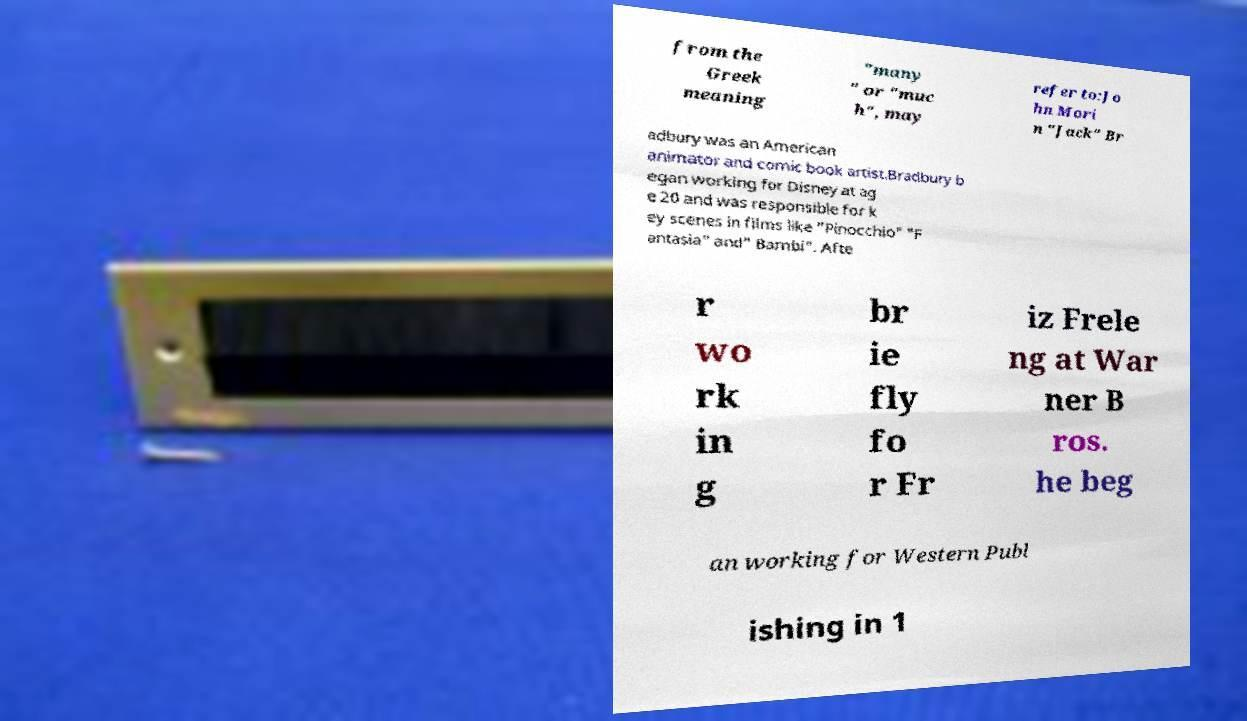Could you assist in decoding the text presented in this image and type it out clearly? from the Greek meaning "many " or "muc h", may refer to:Jo hn Mori n "Jack" Br adbury was an American animator and comic book artist.Bradbury b egan working for Disney at ag e 20 and was responsible for k ey scenes in films like "Pinocchio" "F antasia" and" Bambi". Afte r wo rk in g br ie fly fo r Fr iz Frele ng at War ner B ros. he beg an working for Western Publ ishing in 1 